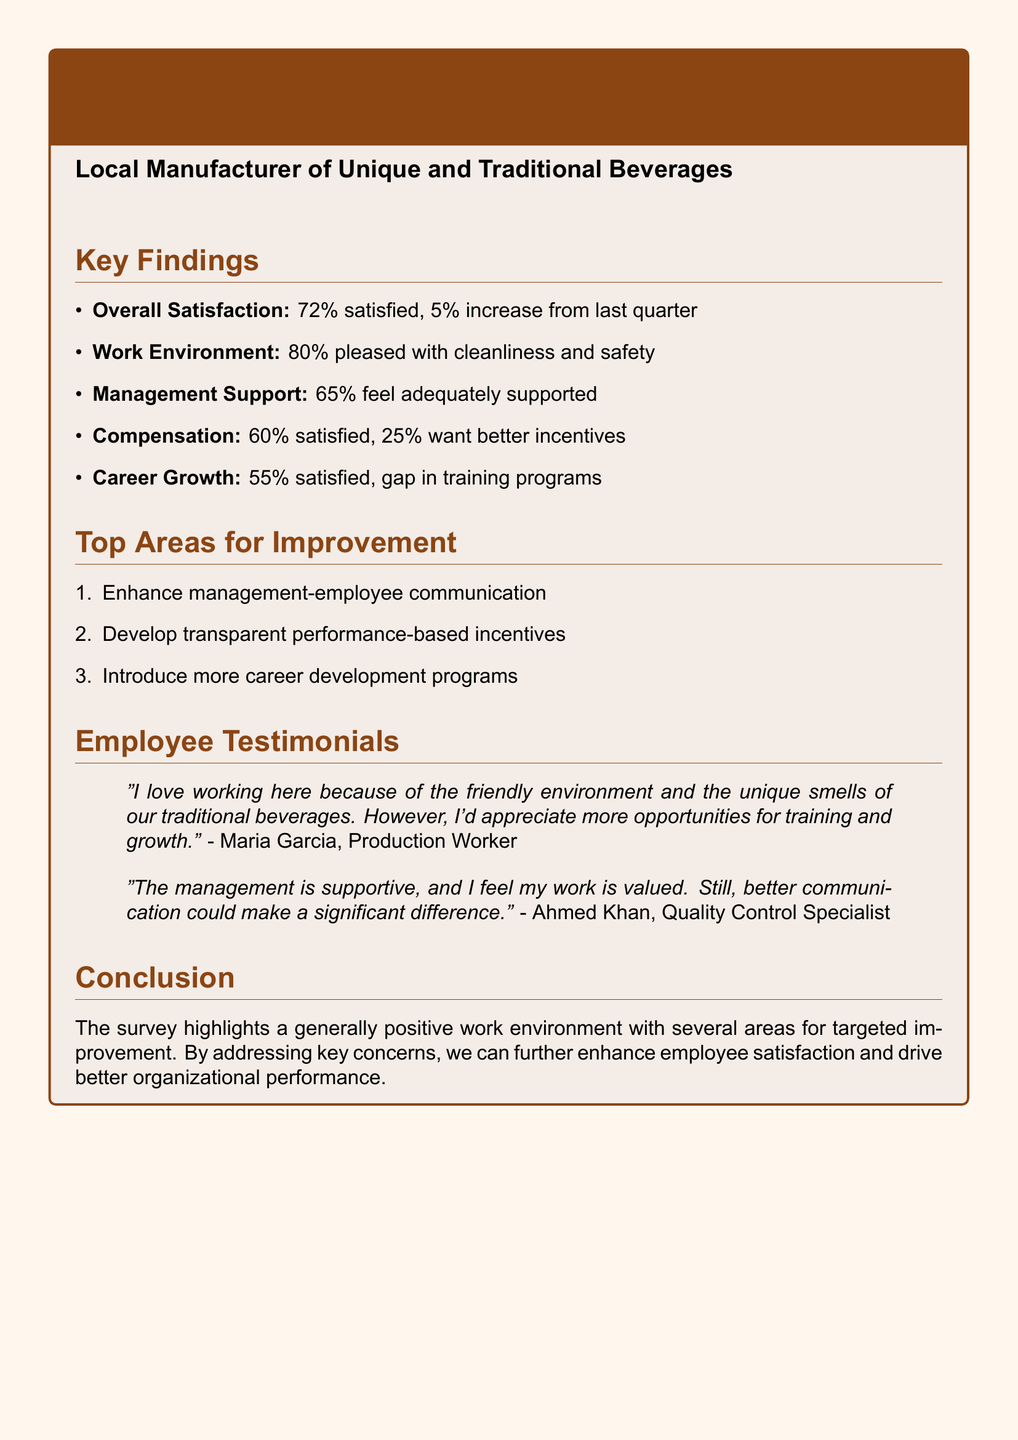What was the overall employee satisfaction percentage? The overall employee satisfaction percentage is stated in the document as 72%.
Answer: 72% How much did employee satisfaction increase from last quarter? The document mentions a 5% increase from the last quarter.
Answer: 5% What percentage of employees feel adequately supported by management? The percentage of employees who feel adequately supported by management is given as 65%.
Answer: 65% What is the satisfaction rate regarding compensation? The satisfaction rate regarding compensation is indicated as 60%.
Answer: 60% What is the top area identified for improvement? The first top area for improvement listed is enhancing management-employee communication.
Answer: Enhance management-employee communication Which employee expressed appreciation for the friendly environment? The employee who expressed appreciation for the friendly environment is Maria Garcia.
Answer: Maria Garcia What percentage of employees are satisfied with their career growth opportunities? The document states that 55% of employees are satisfied with their career growth opportunities.
Answer: 55% What issue was raised regarding training programs? The issue raised is a gap in training programs.
Answer: Gap in training programs What sentiment did Ahmed Khan express about management support? Ahmed Khan expressed that the management is supportive and values his work.
Answer: Supportive and values work 